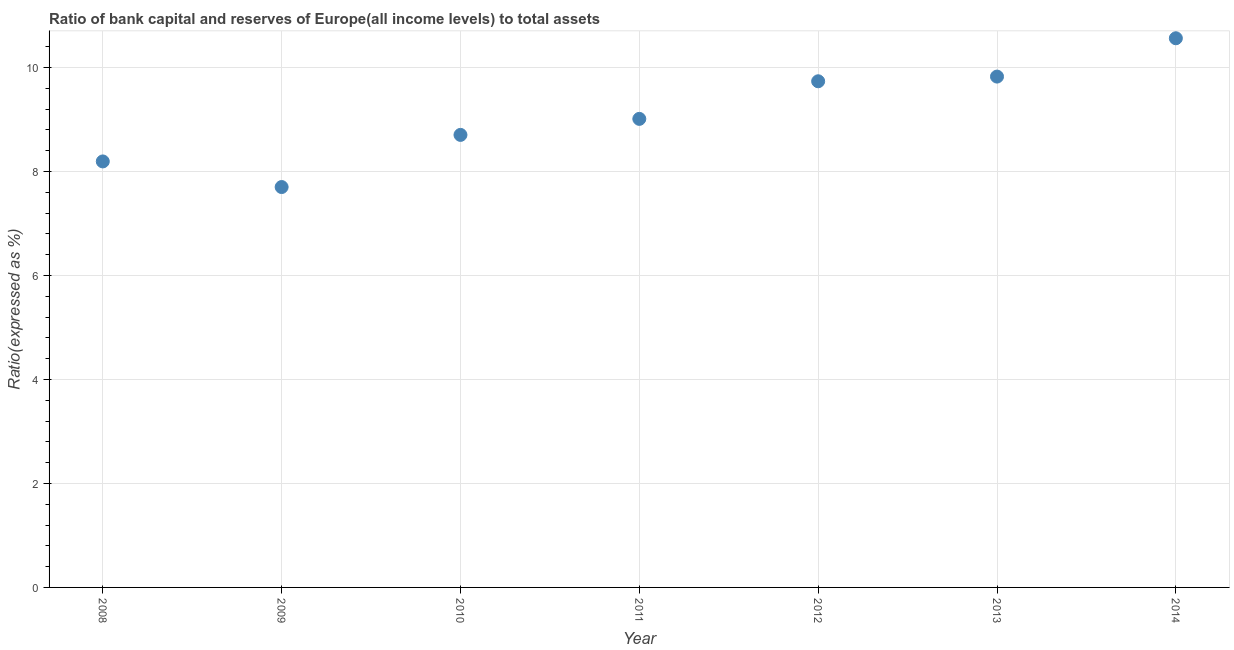What is the bank capital to assets ratio in 2013?
Ensure brevity in your answer.  9.83. Across all years, what is the maximum bank capital to assets ratio?
Offer a very short reply. 10.56. Across all years, what is the minimum bank capital to assets ratio?
Offer a terse response. 7.7. In which year was the bank capital to assets ratio maximum?
Your response must be concise. 2014. In which year was the bank capital to assets ratio minimum?
Ensure brevity in your answer.  2009. What is the sum of the bank capital to assets ratio?
Your response must be concise. 63.74. What is the difference between the bank capital to assets ratio in 2008 and 2011?
Your answer should be compact. -0.82. What is the average bank capital to assets ratio per year?
Offer a very short reply. 9.11. What is the median bank capital to assets ratio?
Your response must be concise. 9.01. In how many years, is the bank capital to assets ratio greater than 3.2 %?
Provide a short and direct response. 7. What is the ratio of the bank capital to assets ratio in 2010 to that in 2012?
Keep it short and to the point. 0.89. What is the difference between the highest and the second highest bank capital to assets ratio?
Your answer should be compact. 0.74. What is the difference between the highest and the lowest bank capital to assets ratio?
Give a very brief answer. 2.86. In how many years, is the bank capital to assets ratio greater than the average bank capital to assets ratio taken over all years?
Give a very brief answer. 3. Are the values on the major ticks of Y-axis written in scientific E-notation?
Offer a very short reply. No. Does the graph contain grids?
Your answer should be very brief. Yes. What is the title of the graph?
Offer a terse response. Ratio of bank capital and reserves of Europe(all income levels) to total assets. What is the label or title of the X-axis?
Offer a terse response. Year. What is the label or title of the Y-axis?
Ensure brevity in your answer.  Ratio(expressed as %). What is the Ratio(expressed as %) in 2008?
Ensure brevity in your answer.  8.19. What is the Ratio(expressed as %) in 2009?
Make the answer very short. 7.7. What is the Ratio(expressed as %) in 2010?
Provide a succinct answer. 8.7. What is the Ratio(expressed as %) in 2011?
Provide a succinct answer. 9.01. What is the Ratio(expressed as %) in 2012?
Your answer should be compact. 9.74. What is the Ratio(expressed as %) in 2013?
Provide a succinct answer. 9.83. What is the Ratio(expressed as %) in 2014?
Ensure brevity in your answer.  10.56. What is the difference between the Ratio(expressed as %) in 2008 and 2009?
Offer a very short reply. 0.49. What is the difference between the Ratio(expressed as %) in 2008 and 2010?
Make the answer very short. -0.51. What is the difference between the Ratio(expressed as %) in 2008 and 2011?
Your answer should be very brief. -0.82. What is the difference between the Ratio(expressed as %) in 2008 and 2012?
Provide a short and direct response. -1.54. What is the difference between the Ratio(expressed as %) in 2008 and 2013?
Your answer should be very brief. -1.63. What is the difference between the Ratio(expressed as %) in 2008 and 2014?
Provide a succinct answer. -2.37. What is the difference between the Ratio(expressed as %) in 2009 and 2010?
Make the answer very short. -1. What is the difference between the Ratio(expressed as %) in 2009 and 2011?
Provide a short and direct response. -1.31. What is the difference between the Ratio(expressed as %) in 2009 and 2012?
Offer a terse response. -2.03. What is the difference between the Ratio(expressed as %) in 2009 and 2013?
Keep it short and to the point. -2.12. What is the difference between the Ratio(expressed as %) in 2009 and 2014?
Your response must be concise. -2.86. What is the difference between the Ratio(expressed as %) in 2010 and 2011?
Offer a terse response. -0.31. What is the difference between the Ratio(expressed as %) in 2010 and 2012?
Make the answer very short. -1.03. What is the difference between the Ratio(expressed as %) in 2010 and 2013?
Give a very brief answer. -1.12. What is the difference between the Ratio(expressed as %) in 2010 and 2014?
Offer a terse response. -1.86. What is the difference between the Ratio(expressed as %) in 2011 and 2012?
Provide a succinct answer. -0.72. What is the difference between the Ratio(expressed as %) in 2011 and 2013?
Offer a terse response. -0.81. What is the difference between the Ratio(expressed as %) in 2011 and 2014?
Give a very brief answer. -1.55. What is the difference between the Ratio(expressed as %) in 2012 and 2013?
Give a very brief answer. -0.09. What is the difference between the Ratio(expressed as %) in 2012 and 2014?
Offer a terse response. -0.83. What is the difference between the Ratio(expressed as %) in 2013 and 2014?
Keep it short and to the point. -0.74. What is the ratio of the Ratio(expressed as %) in 2008 to that in 2009?
Offer a very short reply. 1.06. What is the ratio of the Ratio(expressed as %) in 2008 to that in 2010?
Offer a very short reply. 0.94. What is the ratio of the Ratio(expressed as %) in 2008 to that in 2011?
Ensure brevity in your answer.  0.91. What is the ratio of the Ratio(expressed as %) in 2008 to that in 2012?
Give a very brief answer. 0.84. What is the ratio of the Ratio(expressed as %) in 2008 to that in 2013?
Offer a very short reply. 0.83. What is the ratio of the Ratio(expressed as %) in 2008 to that in 2014?
Your answer should be very brief. 0.78. What is the ratio of the Ratio(expressed as %) in 2009 to that in 2010?
Give a very brief answer. 0.89. What is the ratio of the Ratio(expressed as %) in 2009 to that in 2011?
Your response must be concise. 0.85. What is the ratio of the Ratio(expressed as %) in 2009 to that in 2012?
Your response must be concise. 0.79. What is the ratio of the Ratio(expressed as %) in 2009 to that in 2013?
Give a very brief answer. 0.78. What is the ratio of the Ratio(expressed as %) in 2009 to that in 2014?
Ensure brevity in your answer.  0.73. What is the ratio of the Ratio(expressed as %) in 2010 to that in 2012?
Offer a very short reply. 0.89. What is the ratio of the Ratio(expressed as %) in 2010 to that in 2013?
Keep it short and to the point. 0.89. What is the ratio of the Ratio(expressed as %) in 2010 to that in 2014?
Offer a very short reply. 0.82. What is the ratio of the Ratio(expressed as %) in 2011 to that in 2012?
Provide a short and direct response. 0.93. What is the ratio of the Ratio(expressed as %) in 2011 to that in 2013?
Offer a terse response. 0.92. What is the ratio of the Ratio(expressed as %) in 2011 to that in 2014?
Give a very brief answer. 0.85. What is the ratio of the Ratio(expressed as %) in 2012 to that in 2013?
Provide a succinct answer. 0.99. What is the ratio of the Ratio(expressed as %) in 2012 to that in 2014?
Ensure brevity in your answer.  0.92. What is the ratio of the Ratio(expressed as %) in 2013 to that in 2014?
Ensure brevity in your answer.  0.93. 